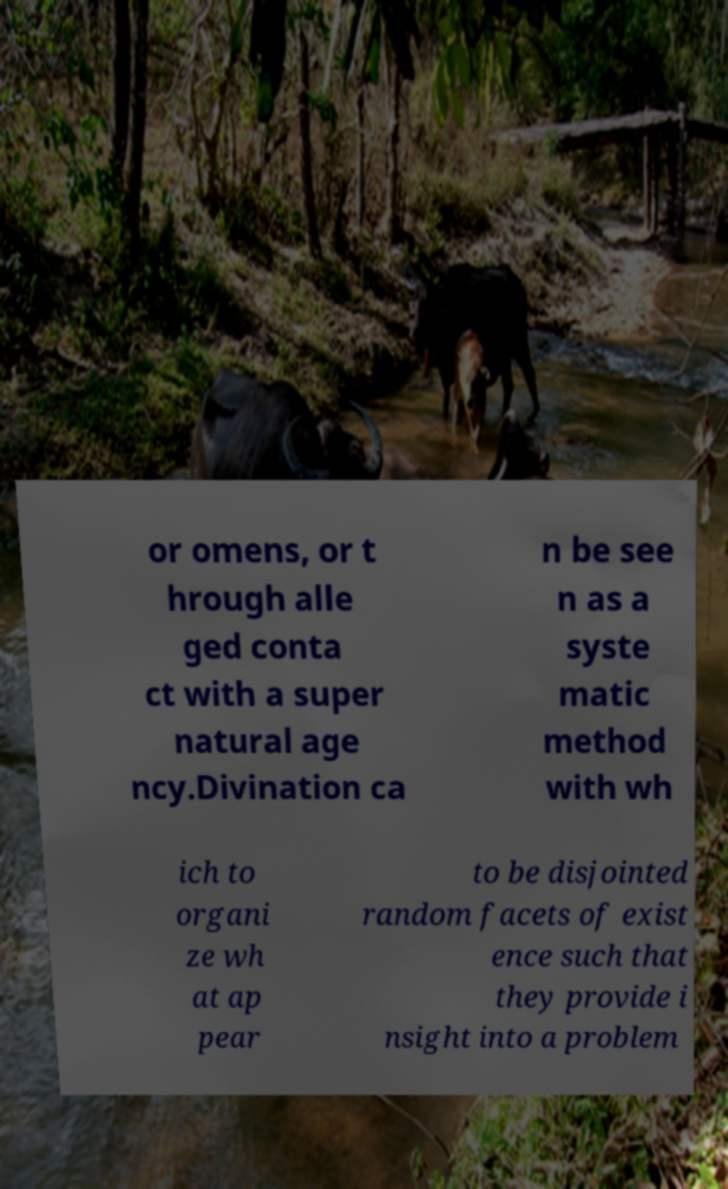What messages or text are displayed in this image? I need them in a readable, typed format. or omens, or t hrough alle ged conta ct with a super natural age ncy.Divination ca n be see n as a syste matic method with wh ich to organi ze wh at ap pear to be disjointed random facets of exist ence such that they provide i nsight into a problem 